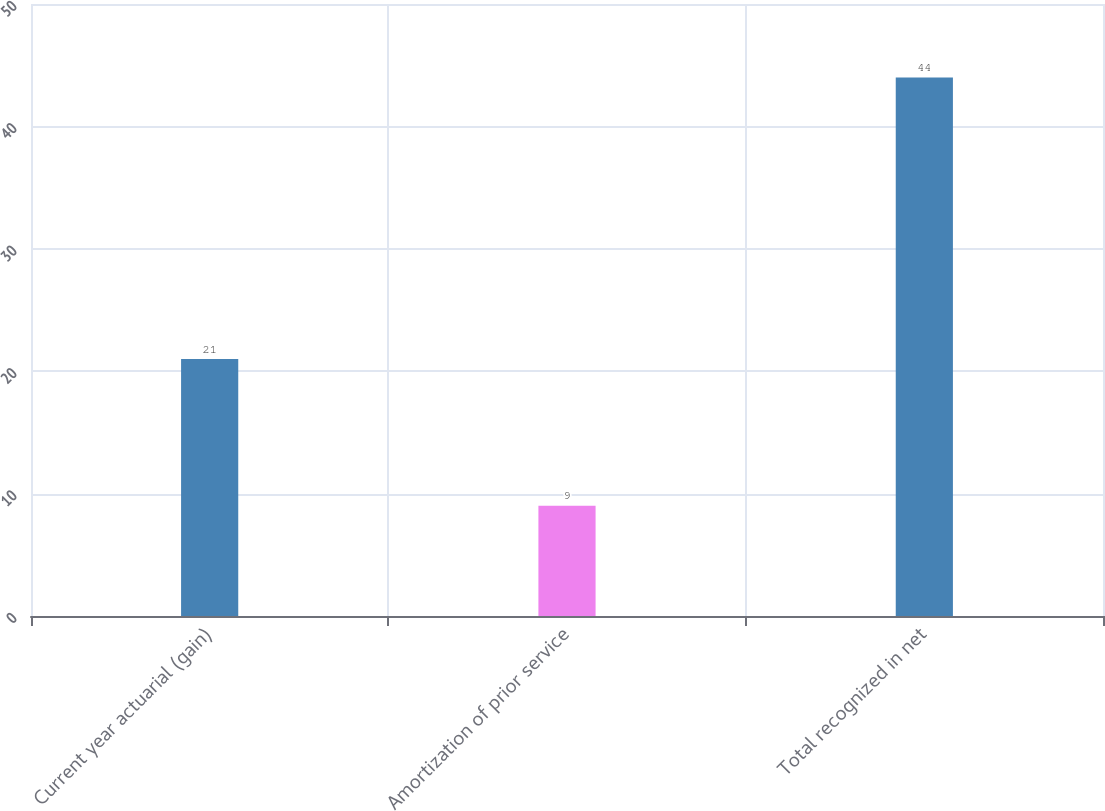Convert chart. <chart><loc_0><loc_0><loc_500><loc_500><bar_chart><fcel>Current year actuarial (gain)<fcel>Amortization of prior service<fcel>Total recognized in net<nl><fcel>21<fcel>9<fcel>44<nl></chart> 